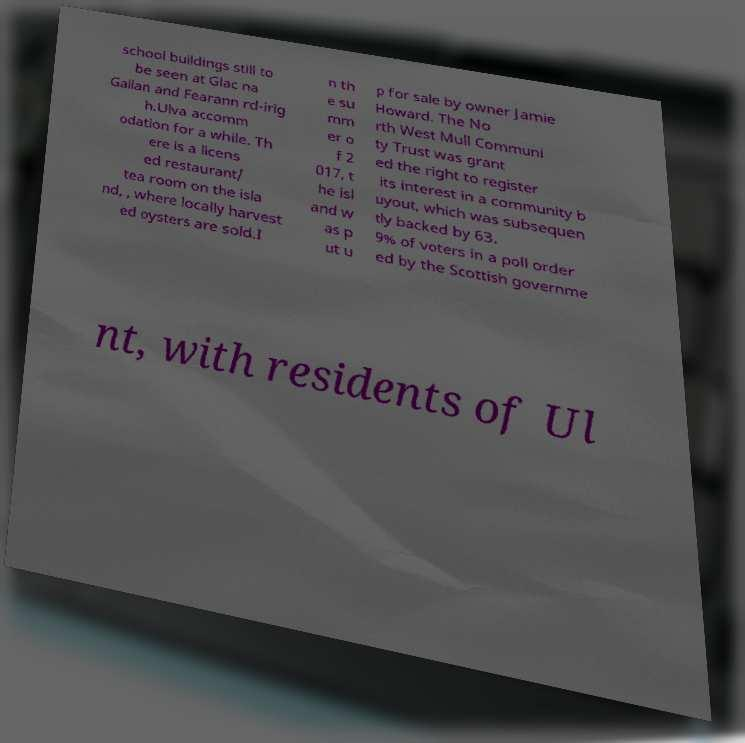What messages or text are displayed in this image? I need them in a readable, typed format. school buildings still to be seen at Glac na Gallan and Fearann rd-irig h.Ulva accomm odation for a while. Th ere is a licens ed restaurant/ tea room on the isla nd, , where locally harvest ed oysters are sold.I n th e su mm er o f 2 017, t he isl and w as p ut u p for sale by owner Jamie Howard. The No rth West Mull Communi ty Trust was grant ed the right to register its interest in a community b uyout, which was subsequen tly backed by 63. 9% of voters in a poll order ed by the Scottish governme nt, with residents of Ul 